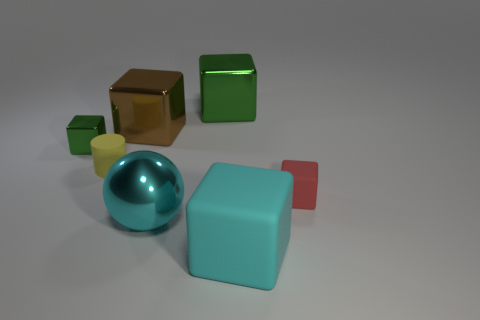Subtract all big metal cubes. How many cubes are left? 3 Subtract all red cylinders. How many green cubes are left? 2 Add 1 matte blocks. How many objects exist? 8 Subtract 3 cubes. How many cubes are left? 2 Subtract all brown cubes. How many cubes are left? 4 Subtract all green blocks. Subtract all yellow cylinders. How many blocks are left? 3 Subtract all balls. How many objects are left? 6 Subtract all blocks. Subtract all large cyan shiny objects. How many objects are left? 1 Add 2 big metal spheres. How many big metal spheres are left? 3 Add 3 small blue rubber cylinders. How many small blue rubber cylinders exist? 3 